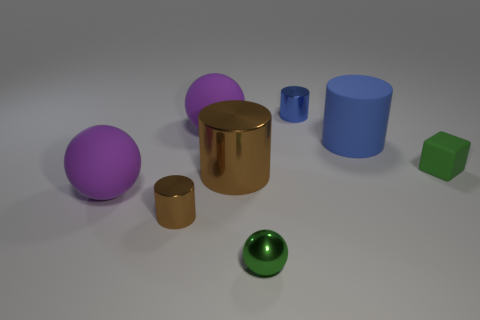The other matte thing that is the same shape as the small blue object is what size?
Your response must be concise. Large. Are there the same number of purple objects that are to the right of the big blue cylinder and green metal spheres in front of the tiny rubber object?
Make the answer very short. No. What number of other things are the same material as the big brown cylinder?
Offer a terse response. 3. Are there an equal number of tiny blue objects right of the blue metallic object and small brown metal things?
Provide a succinct answer. No. There is a green shiny ball; does it have the same size as the blue object that is to the right of the blue metal object?
Your answer should be very brief. No. What shape is the small green object behind the small green sphere?
Keep it short and to the point. Cube. Is there anything else that is the same shape as the tiny rubber thing?
Give a very brief answer. No. Are any large red objects visible?
Your answer should be very brief. No. There is a purple ball that is in front of the big brown metal thing; is it the same size as the green thing in front of the small matte cube?
Offer a terse response. No. There is a cylinder that is both to the left of the big blue object and behind the tiny green matte object; what is its material?
Your answer should be very brief. Metal. 